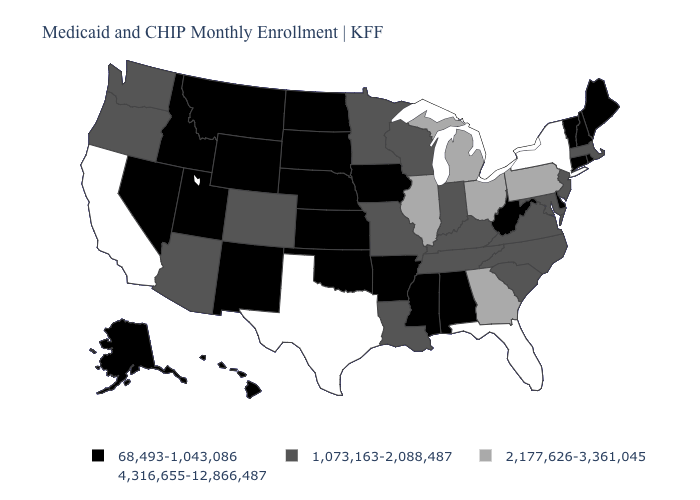Name the states that have a value in the range 4,316,655-12,866,487?
Quick response, please. California, Florida, New York, Texas. What is the value of West Virginia?
Give a very brief answer. 68,493-1,043,086. Does North Dakota have a higher value than Colorado?
Be succinct. No. What is the value of North Carolina?
Short answer required. 1,073,163-2,088,487. Does Oklahoma have the same value as Mississippi?
Give a very brief answer. Yes. Name the states that have a value in the range 68,493-1,043,086?
Be succinct. Alabama, Alaska, Arkansas, Connecticut, Delaware, Hawaii, Idaho, Iowa, Kansas, Maine, Mississippi, Montana, Nebraska, Nevada, New Hampshire, New Mexico, North Dakota, Oklahoma, Rhode Island, South Dakota, Utah, Vermont, West Virginia, Wyoming. What is the value of Virginia?
Write a very short answer. 1,073,163-2,088,487. What is the value of Oklahoma?
Concise answer only. 68,493-1,043,086. What is the value of Ohio?
Write a very short answer. 2,177,626-3,361,045. How many symbols are there in the legend?
Give a very brief answer. 4. Which states hav the highest value in the South?
Keep it brief. Florida, Texas. What is the highest value in states that border Montana?
Concise answer only. 68,493-1,043,086. Does West Virginia have the lowest value in the USA?
Write a very short answer. Yes. Among the states that border Indiana , which have the lowest value?
Keep it brief. Kentucky. What is the highest value in states that border Delaware?
Short answer required. 2,177,626-3,361,045. 